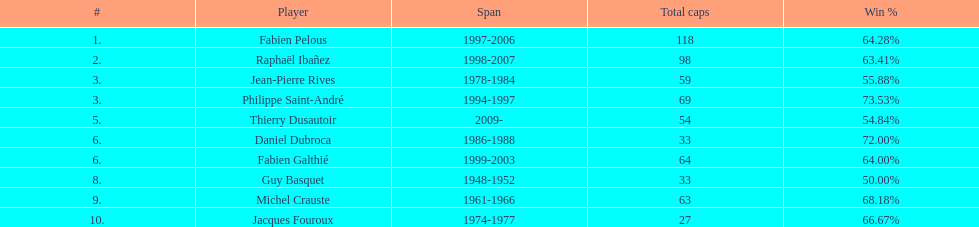Which captain served for the least duration? Daniel Dubroca. 